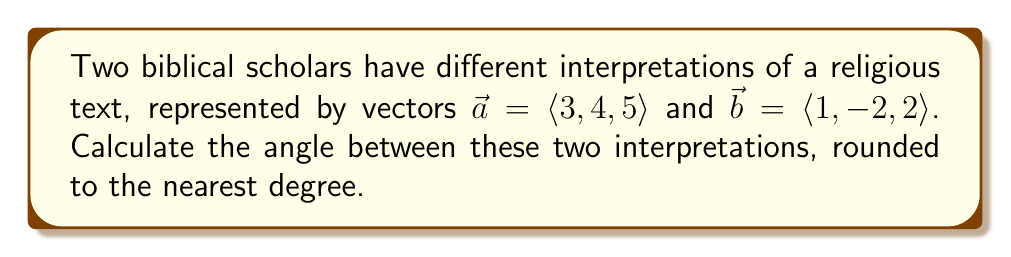Show me your answer to this math problem. To find the angle between two vectors, we'll use the dot product formula:

$$\cos \theta = \frac{\vec{a} \cdot \vec{b}}{|\vec{a}||\vec{b}|}$$

Step 1: Calculate the dot product $\vec{a} \cdot \vec{b}$
$$\vec{a} \cdot \vec{b} = (3)(1) + (4)(-2) + (5)(2) = 3 - 8 + 10 = 5$$

Step 2: Calculate the magnitudes of $\vec{a}$ and $\vec{b}$
$$|\vec{a}| = \sqrt{3^2 + 4^2 + 5^2} = \sqrt{50}$$
$$|\vec{b}| = \sqrt{1^2 + (-2)^2 + 2^2} = \sqrt{9} = 3$$

Step 3: Substitute into the formula
$$\cos \theta = \frac{5}{\sqrt{50} \cdot 3}$$

Step 4: Simplify
$$\cos \theta = \frac{5}{3\sqrt{50}} = \frac{5}{3\sqrt{2} \cdot 5} = \frac{1}{3\sqrt{2}}$$

Step 5: Take the inverse cosine (arccos) of both sides
$$\theta = \arccos(\frac{1}{3\sqrt{2}})$$

Step 6: Calculate and round to the nearest degree
$$\theta \approx 75^\circ$$

This angle represents the divergence between the two scholars' interpretations, with larger angles indicating greater differences in understanding.
Answer: $75^\circ$ 